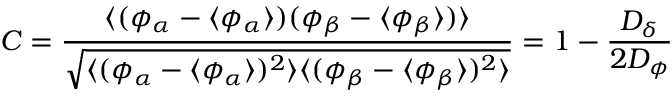<formula> <loc_0><loc_0><loc_500><loc_500>C = \frac { \langle ( \phi _ { \alpha } - \langle \phi _ { \alpha } \rangle ) ( \phi _ { \beta } - \langle \phi _ { \beta } \rangle ) \rangle } { \sqrt { \langle ( \phi _ { \alpha } - \langle \phi _ { \alpha } \rangle ) ^ { 2 } \rangle \langle ( \phi _ { \beta } - \langle \phi _ { \beta } \rangle ) ^ { 2 } \rangle } } = 1 - \frac { D _ { \delta } } { 2 D _ { \phi } }</formula> 